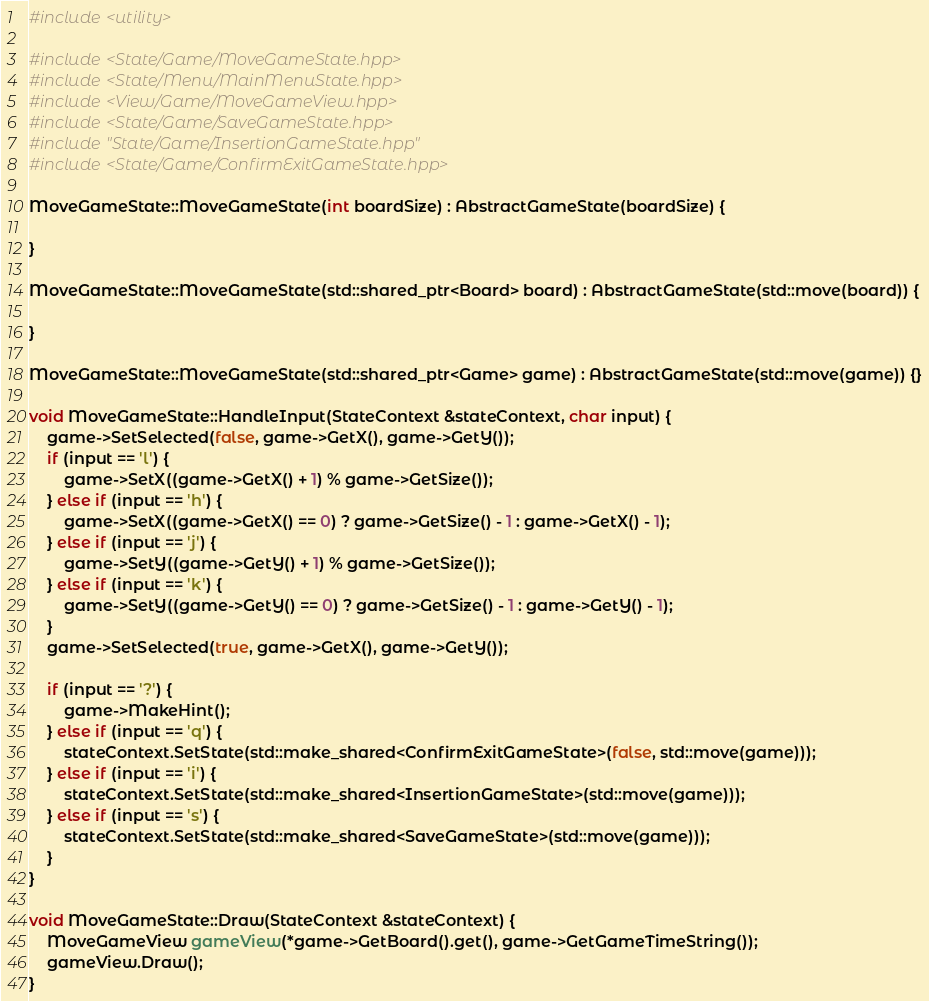<code> <loc_0><loc_0><loc_500><loc_500><_C++_>#include <utility>

#include <State/Game/MoveGameState.hpp>
#include <State/Menu/MainMenuState.hpp>
#include <View/Game/MoveGameView.hpp>
#include <State/Game/SaveGameState.hpp>
#include "State/Game/InsertionGameState.hpp"
#include <State/Game/ConfirmExitGameState.hpp>

MoveGameState::MoveGameState(int boardSize) : AbstractGameState(boardSize) {

}

MoveGameState::MoveGameState(std::shared_ptr<Board> board) : AbstractGameState(std::move(board)) {

}

MoveGameState::MoveGameState(std::shared_ptr<Game> game) : AbstractGameState(std::move(game)) {}

void MoveGameState::HandleInput(StateContext &stateContext, char input) {
    game->SetSelected(false, game->GetX(), game->GetY());
    if (input == 'l') {
        game->SetX((game->GetX() + 1) % game->GetSize());
    } else if (input == 'h') {
        game->SetX((game->GetX() == 0) ? game->GetSize() - 1 : game->GetX() - 1);
    } else if (input == 'j') {
        game->SetY((game->GetY() + 1) % game->GetSize());
    } else if (input == 'k') {
        game->SetY((game->GetY() == 0) ? game->GetSize() - 1 : game->GetY() - 1);
    }
    game->SetSelected(true, game->GetX(), game->GetY());

    if (input == '?') {
        game->MakeHint();
    } else if (input == 'q') {
        stateContext.SetState(std::make_shared<ConfirmExitGameState>(false, std::move(game)));
    } else if (input == 'i') {
        stateContext.SetState(std::make_shared<InsertionGameState>(std::move(game)));
    } else if (input == 's') {
        stateContext.SetState(std::make_shared<SaveGameState>(std::move(game)));
    }
}

void MoveGameState::Draw(StateContext &stateContext) {
    MoveGameView gameView(*game->GetBoard().get(), game->GetGameTimeString());
    gameView.Draw();
}
</code> 